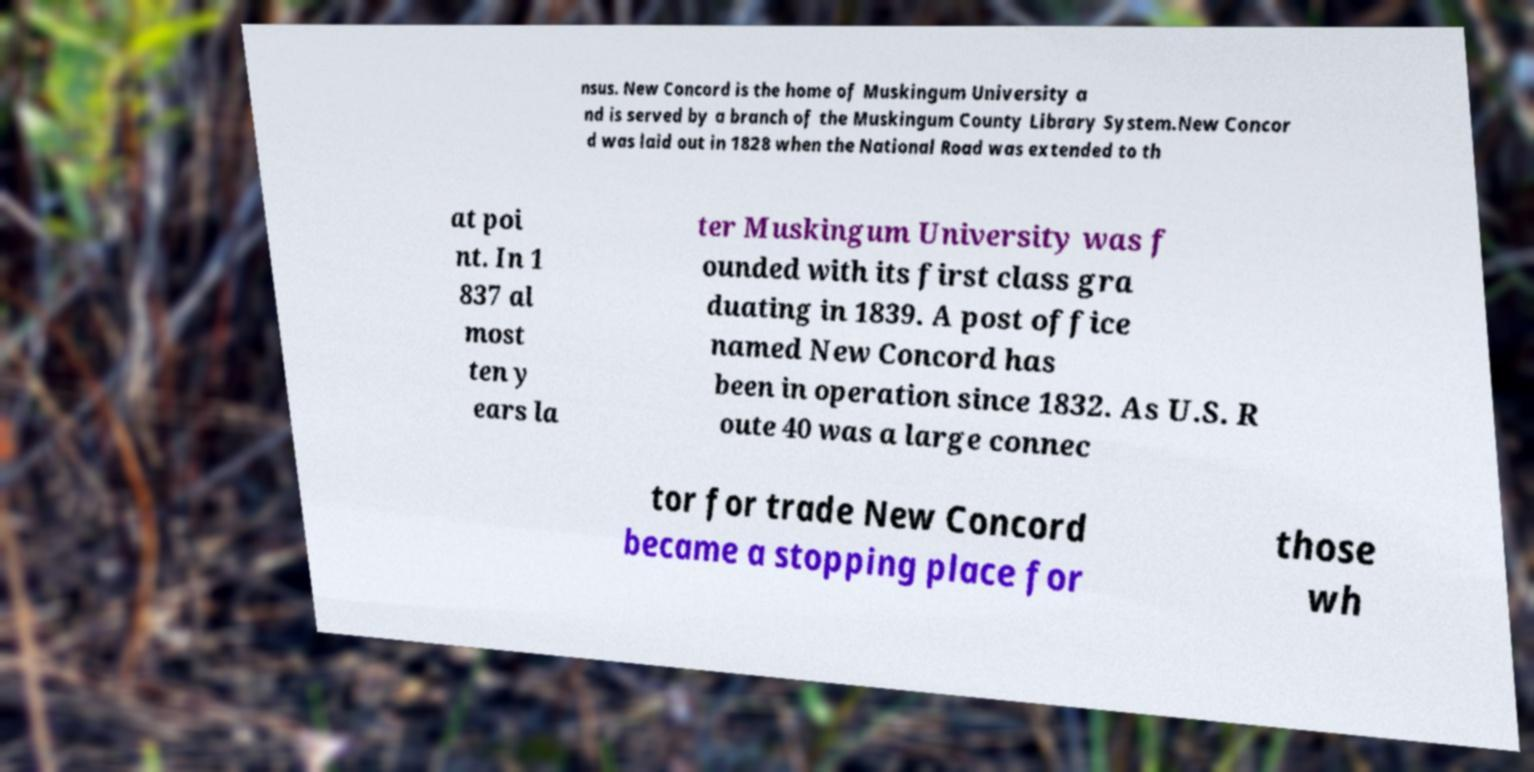For documentation purposes, I need the text within this image transcribed. Could you provide that? nsus. New Concord is the home of Muskingum University a nd is served by a branch of the Muskingum County Library System.New Concor d was laid out in 1828 when the National Road was extended to th at poi nt. In 1 837 al most ten y ears la ter Muskingum University was f ounded with its first class gra duating in 1839. A post office named New Concord has been in operation since 1832. As U.S. R oute 40 was a large connec tor for trade New Concord became a stopping place for those wh 